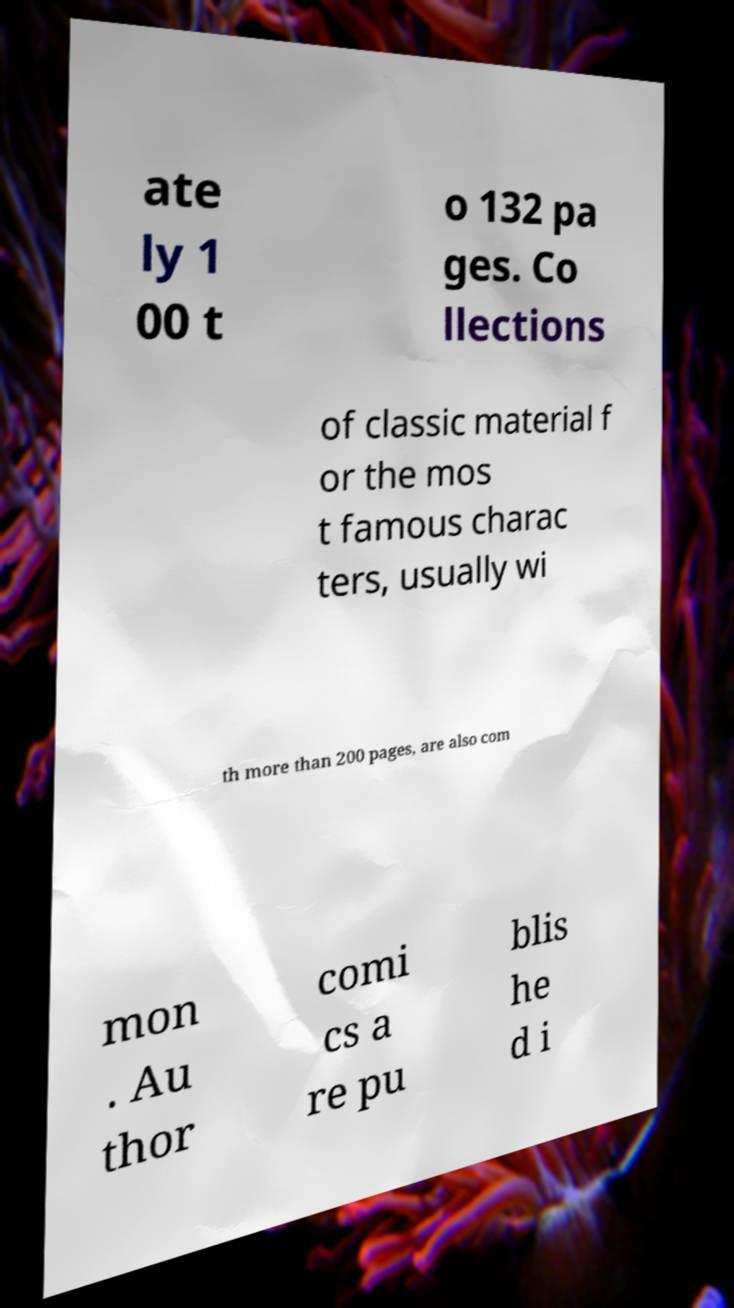Please read and relay the text visible in this image. What does it say? ate ly 1 00 t o 132 pa ges. Co llections of classic material f or the mos t famous charac ters, usually wi th more than 200 pages, are also com mon . Au thor comi cs a re pu blis he d i 